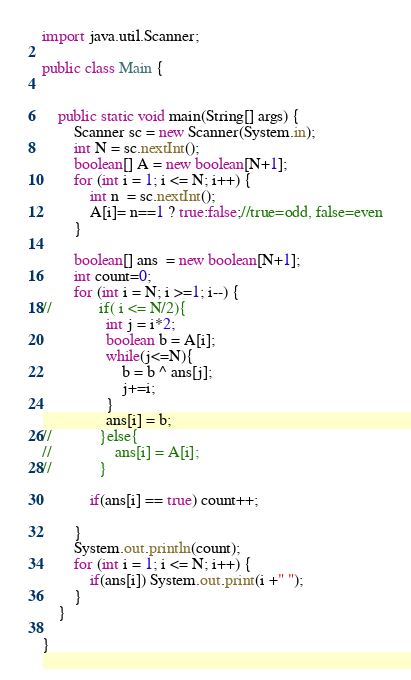Convert code to text. <code><loc_0><loc_0><loc_500><loc_500><_Java_>import java.util.Scanner;

public class Main {


    public static void main(String[] args) {
        Scanner sc = new Scanner(System.in);
        int N = sc.nextInt();
        boolean[] A = new boolean[N+1];
        for (int i = 1; i <= N; i++) {
            int n  = sc.nextInt();
            A[i]= n==1 ? true:false;//true=odd, false=even
        }

        boolean[] ans  = new boolean[N+1];
        int count=0;
        for (int i = N; i >=1; i--) {
//            if( i <= N/2){
                int j = i*2;
                boolean b = A[i];
                while(j<=N){
                    b = b ^ ans[j];
                    j+=i;
                }
                ans[i] = b;
//            }else{
//                ans[i] = A[i];
//            }

            if(ans[i] == true) count++;

        }
        System.out.println(count);
        for (int i = 1; i <= N; i++) {
            if(ans[i]) System.out.print(i +" ");
        }
    }

}
</code> 